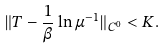<formula> <loc_0><loc_0><loc_500><loc_500>\| T - \frac { 1 } { \beta } \ln \mu ^ { - 1 } \| _ { C ^ { 0 } } < K .</formula> 